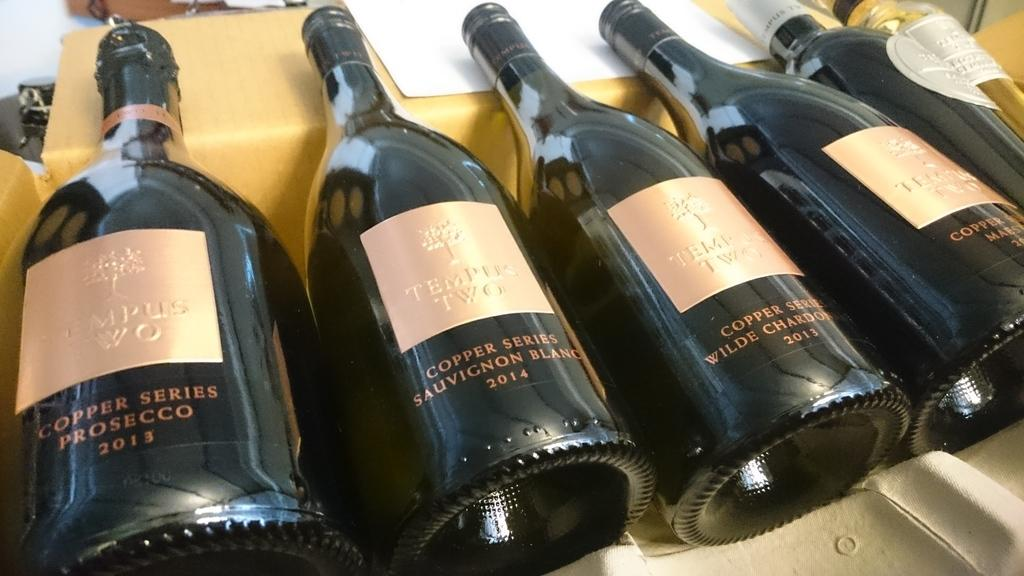What is the primary subject of the image? The primary subject of the image is many wine bottles. Are there any other objects or items in the image besides the wine bottles? Yes, there is a paper in the image. How does the paper express its love for the wine bottles in the image? The paper does not express any emotions, such as love, in the image. The image only shows wine bottles and a paper, without any indication of their relationship or emotions. 